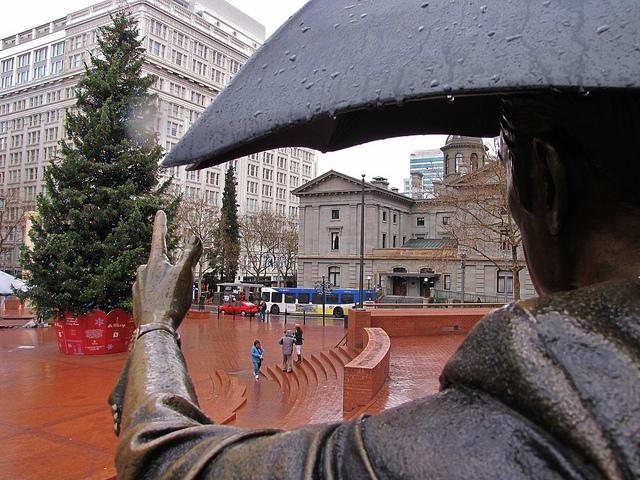When does this season take place? winter 